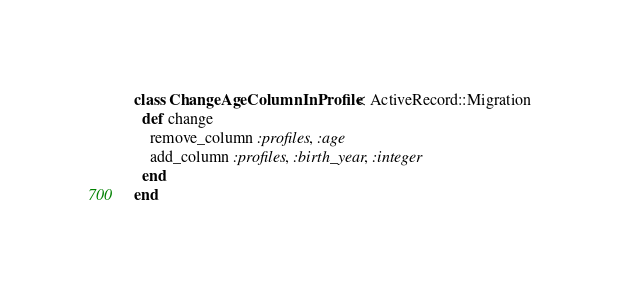Convert code to text. <code><loc_0><loc_0><loc_500><loc_500><_Ruby_>class ChangeAgeColumnInProfile < ActiveRecord::Migration
  def change
    remove_column :profiles, :age
    add_column :profiles, :birth_year, :integer
  end
end
</code> 